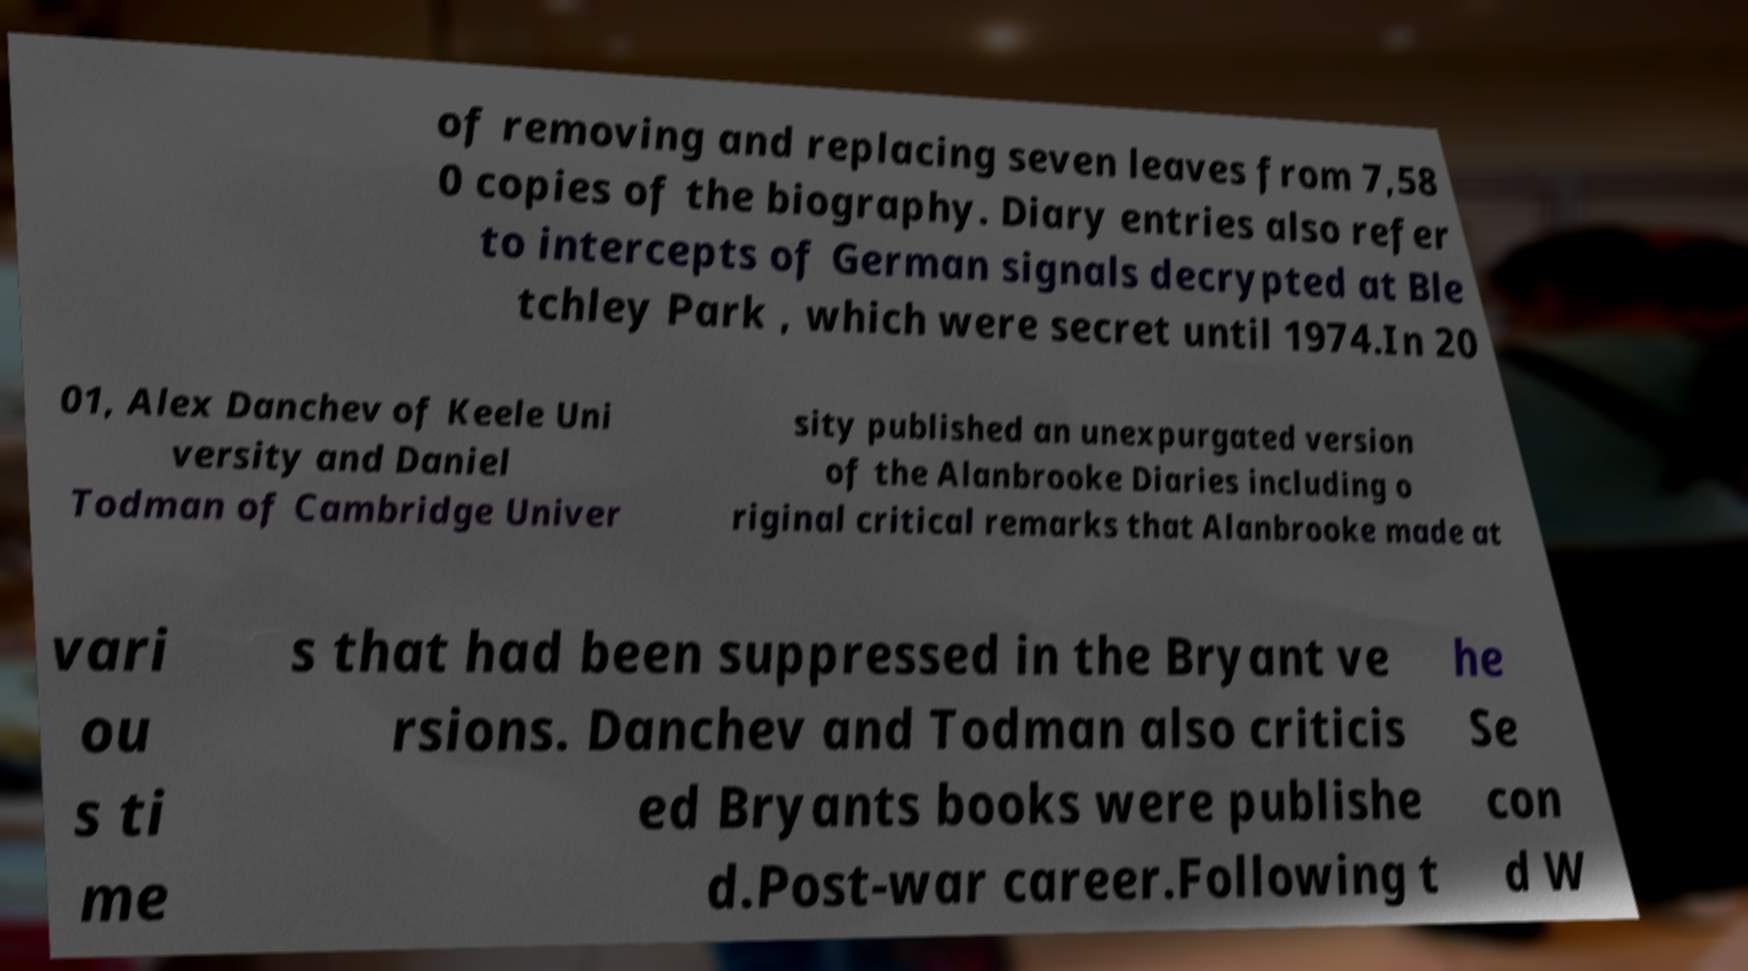For documentation purposes, I need the text within this image transcribed. Could you provide that? of removing and replacing seven leaves from 7,58 0 copies of the biography. Diary entries also refer to intercepts of German signals decrypted at Ble tchley Park , which were secret until 1974.In 20 01, Alex Danchev of Keele Uni versity and Daniel Todman of Cambridge Univer sity published an unexpurgated version of the Alanbrooke Diaries including o riginal critical remarks that Alanbrooke made at vari ou s ti me s that had been suppressed in the Bryant ve rsions. Danchev and Todman also criticis ed Bryants books were publishe d.Post-war career.Following t he Se con d W 